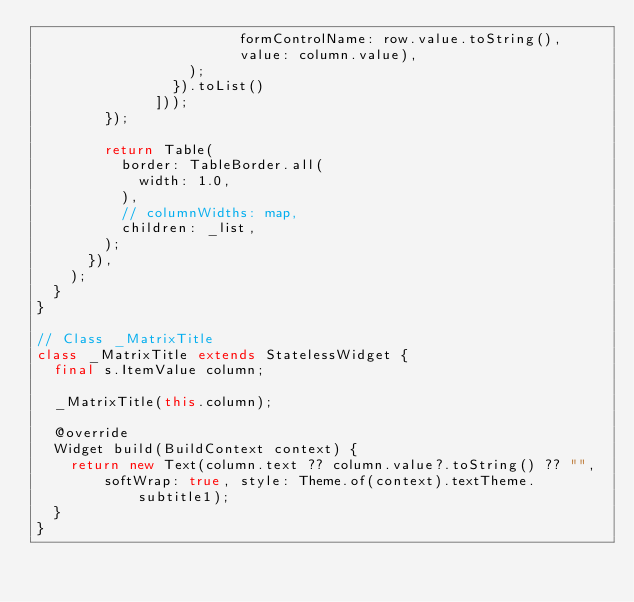<code> <loc_0><loc_0><loc_500><loc_500><_Dart_>                        formControlName: row.value.toString(),
                        value: column.value),
                  );
                }).toList()
              ]));
        });

        return Table(
          border: TableBorder.all(
            width: 1.0,
          ),
          // columnWidths: map,
          children: _list,
        );
      }),
    );
  }
}

// Class _MatrixTitle
class _MatrixTitle extends StatelessWidget {
  final s.ItemValue column;

  _MatrixTitle(this.column);

  @override
  Widget build(BuildContext context) {
    return new Text(column.text ?? column.value?.toString() ?? "",
        softWrap: true, style: Theme.of(context).textTheme.subtitle1);
  }
}
</code> 